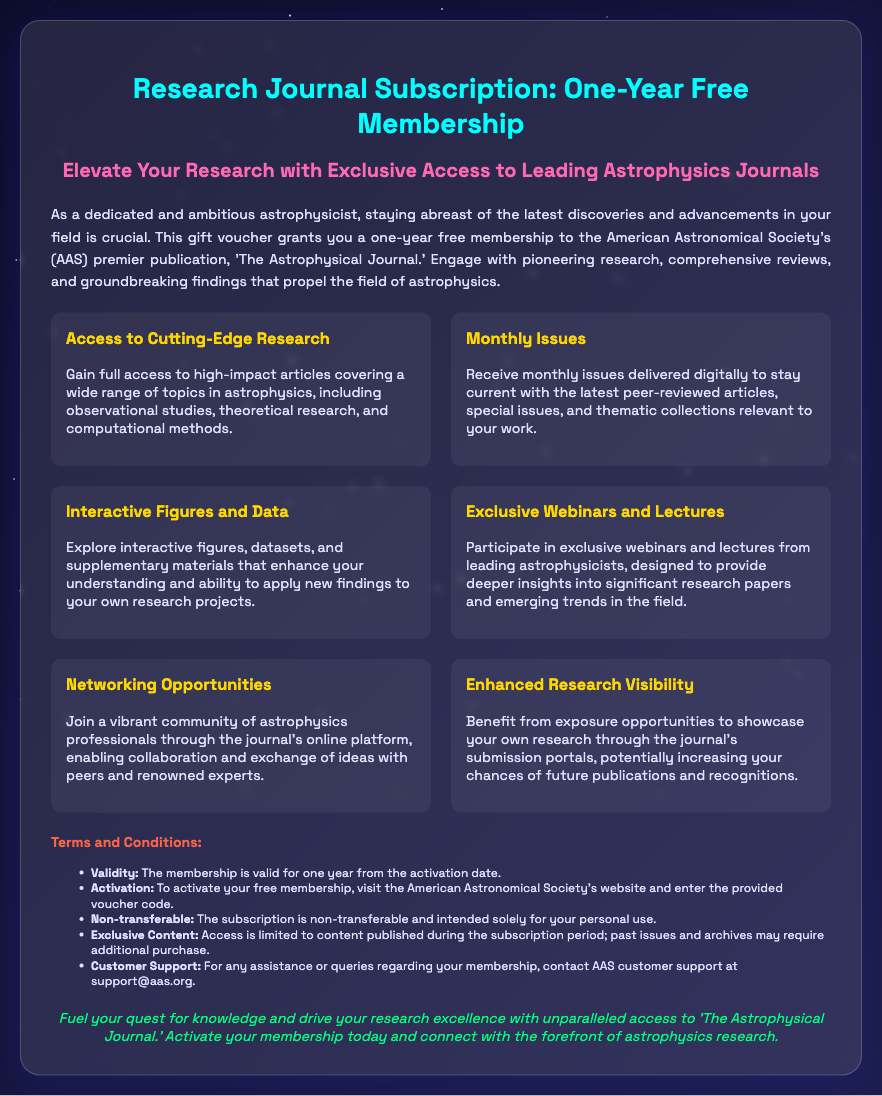What is the journal title associated with the membership? The membership provides a subscription to 'The Astrophysical Journal,' which is explicitly mentioned in the document.
Answer: The Astrophysical Journal How long is the membership valid? The document states the membership is valid for one year from the activation date, indicating the duration of the subscription.
Answer: One year What type of access do you get with this voucher? The voucher grants access to high-impact articles covering various topics in astrophysics, as described in the benefits section.
Answer: Cutting-Edge Research What is one benefit of the subscription? The document lists several benefits; one of them is "Exclusive Webinars and Lectures," pointing out some of the educational advantages of the membership.
Answer: Exclusive Webinars and Lectures What is required to activate the membership? The document states that to activate the membership, one must visit the American Astronomical Society's website and enter the provided voucher code.
Answer: Voucher code Is the subscription transferable? The terms mention that the subscription is non-transferable, providing clarity on the ownership of the membership.
Answer: Non-transferable What does the membership enhance in relation to your own research? The document states the benefit of increased exposure opportunities to showcase your own research through the journal's submission portals.
Answer: Research Visibility What email should be used for customer support? Customer support queries can be directed to support@aas.org, which is provided in the terms section.
Answer: support@aas.org What is one way to stay current with new issues? The document specifies that members receive monthly issues delivered digitally, allowing them to stay updated with new research.
Answer: Monthly Issues 